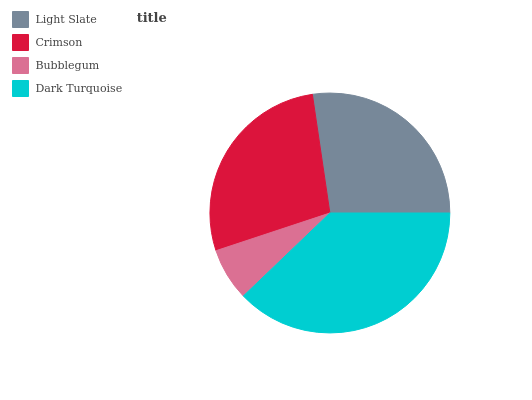Is Bubblegum the minimum?
Answer yes or no. Yes. Is Dark Turquoise the maximum?
Answer yes or no. Yes. Is Crimson the minimum?
Answer yes or no. No. Is Crimson the maximum?
Answer yes or no. No. Is Crimson greater than Light Slate?
Answer yes or no. Yes. Is Light Slate less than Crimson?
Answer yes or no. Yes. Is Light Slate greater than Crimson?
Answer yes or no. No. Is Crimson less than Light Slate?
Answer yes or no. No. Is Crimson the high median?
Answer yes or no. Yes. Is Light Slate the low median?
Answer yes or no. Yes. Is Bubblegum the high median?
Answer yes or no. No. Is Dark Turquoise the low median?
Answer yes or no. No. 